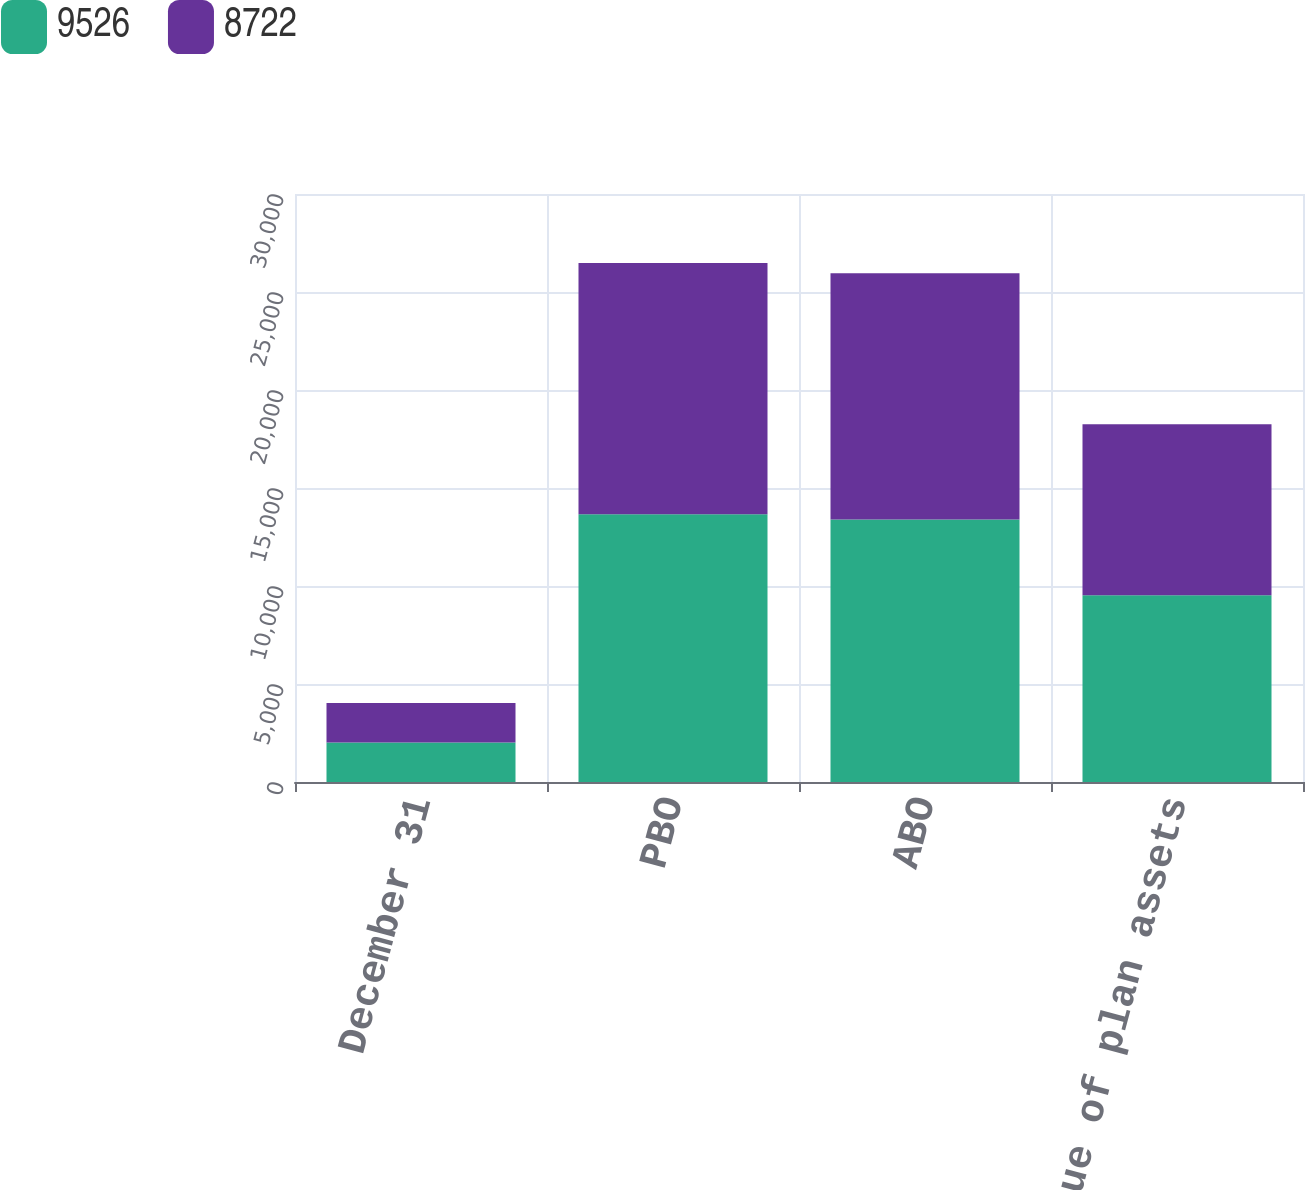Convert chart. <chart><loc_0><loc_0><loc_500><loc_500><stacked_bar_chart><ecel><fcel>December 31<fcel>PBO<fcel>ABO<fcel>Fair value of plan assets<nl><fcel>9526<fcel>2017<fcel>13660<fcel>13398<fcel>9526<nl><fcel>8722<fcel>2016<fcel>12817<fcel>12557<fcel>8722<nl></chart> 